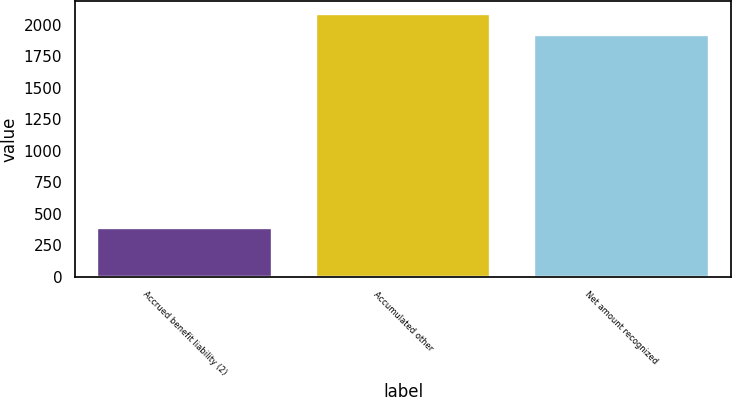Convert chart. <chart><loc_0><loc_0><loc_500><loc_500><bar_chart><fcel>Accrued benefit liability (2)<fcel>Accumulated other<fcel>Net amount recognized<nl><fcel>385<fcel>2083<fcel>1921<nl></chart> 